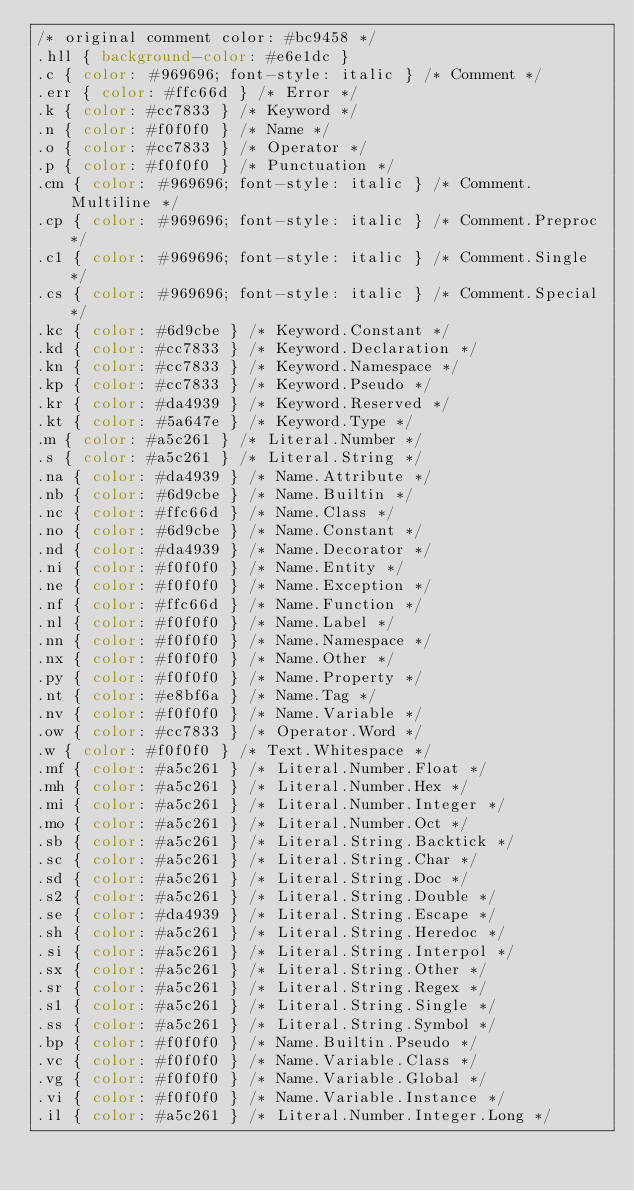Convert code to text. <code><loc_0><loc_0><loc_500><loc_500><_CSS_>/* original comment color: #bc9458 */
.hll { background-color: #e6e1dc }
.c { color: #969696; font-style: italic } /* Comment */
.err { color: #ffc66d } /* Error */
.k { color: #cc7833 } /* Keyword */
.n { color: #f0f0f0 } /* Name */
.o { color: #cc7833 } /* Operator */
.p { color: #f0f0f0 } /* Punctuation */
.cm { color: #969696; font-style: italic } /* Comment.Multiline */
.cp { color: #969696; font-style: italic } /* Comment.Preproc */
.c1 { color: #969696; font-style: italic } /* Comment.Single */
.cs { color: #969696; font-style: italic } /* Comment.Special */
.kc { color: #6d9cbe } /* Keyword.Constant */
.kd { color: #cc7833 } /* Keyword.Declaration */
.kn { color: #cc7833 } /* Keyword.Namespace */
.kp { color: #cc7833 } /* Keyword.Pseudo */
.kr { color: #da4939 } /* Keyword.Reserved */
.kt { color: #5a647e } /* Keyword.Type */
.m { color: #a5c261 } /* Literal.Number */
.s { color: #a5c261 } /* Literal.String */
.na { color: #da4939 } /* Name.Attribute */
.nb { color: #6d9cbe } /* Name.Builtin */
.nc { color: #ffc66d } /* Name.Class */
.no { color: #6d9cbe } /* Name.Constant */
.nd { color: #da4939 } /* Name.Decorator */
.ni { color: #f0f0f0 } /* Name.Entity */
.ne { color: #f0f0f0 } /* Name.Exception */
.nf { color: #ffc66d } /* Name.Function */
.nl { color: #f0f0f0 } /* Name.Label */
.nn { color: #f0f0f0 } /* Name.Namespace */
.nx { color: #f0f0f0 } /* Name.Other */
.py { color: #f0f0f0 } /* Name.Property */
.nt { color: #e8bf6a } /* Name.Tag */
.nv { color: #f0f0f0 } /* Name.Variable */
.ow { color: #cc7833 } /* Operator.Word */
.w { color: #f0f0f0 } /* Text.Whitespace */
.mf { color: #a5c261 } /* Literal.Number.Float */
.mh { color: #a5c261 } /* Literal.Number.Hex */
.mi { color: #a5c261 } /* Literal.Number.Integer */
.mo { color: #a5c261 } /* Literal.Number.Oct */
.sb { color: #a5c261 } /* Literal.String.Backtick */
.sc { color: #a5c261 } /* Literal.String.Char */
.sd { color: #a5c261 } /* Literal.String.Doc */
.s2 { color: #a5c261 } /* Literal.String.Double */
.se { color: #da4939 } /* Literal.String.Escape */
.sh { color: #a5c261 } /* Literal.String.Heredoc */
.si { color: #a5c261 } /* Literal.String.Interpol */
.sx { color: #a5c261 } /* Literal.String.Other */
.sr { color: #a5c261 } /* Literal.String.Regex */
.s1 { color: #a5c261 } /* Literal.String.Single */
.ss { color: #a5c261 } /* Literal.String.Symbol */
.bp { color: #f0f0f0 } /* Name.Builtin.Pseudo */
.vc { color: #f0f0f0 } /* Name.Variable.Class */
.vg { color: #f0f0f0 } /* Name.Variable.Global */
.vi { color: #f0f0f0 } /* Name.Variable.Instance */
.il { color: #a5c261 } /* Literal.Number.Integer.Long */
</code> 